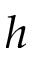Convert formula to latex. <formula><loc_0><loc_0><loc_500><loc_500>h</formula> 